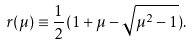Convert formula to latex. <formula><loc_0><loc_0><loc_500><loc_500>r ( \mu ) \equiv \frac { 1 } { 2 } ( 1 + \mu - \sqrt { \mu ^ { 2 } - 1 } ) .</formula> 